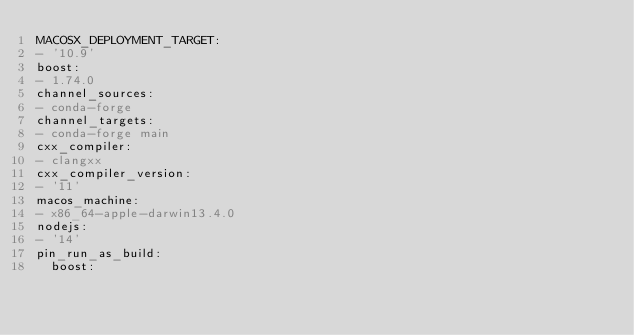<code> <loc_0><loc_0><loc_500><loc_500><_YAML_>MACOSX_DEPLOYMENT_TARGET:
- '10.9'
boost:
- 1.74.0
channel_sources:
- conda-forge
channel_targets:
- conda-forge main
cxx_compiler:
- clangxx
cxx_compiler_version:
- '11'
macos_machine:
- x86_64-apple-darwin13.4.0
nodejs:
- '14'
pin_run_as_build:
  boost:</code> 